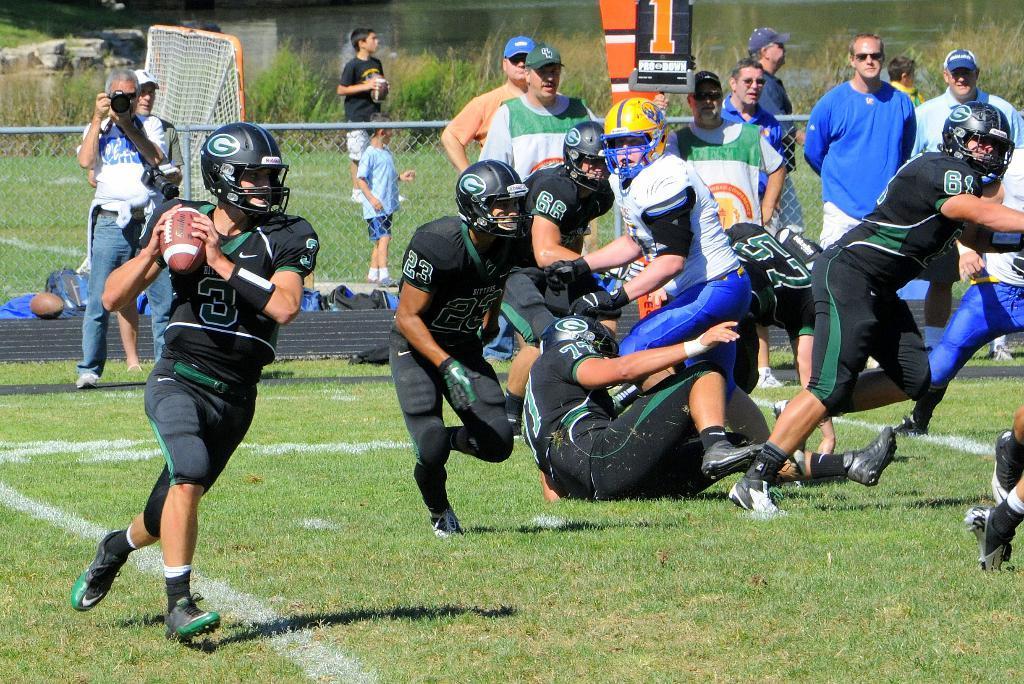Describe this image in one or two sentences. In the center of the image we can see players on the ground. In the background we can see fencing, gross, net and persons. 